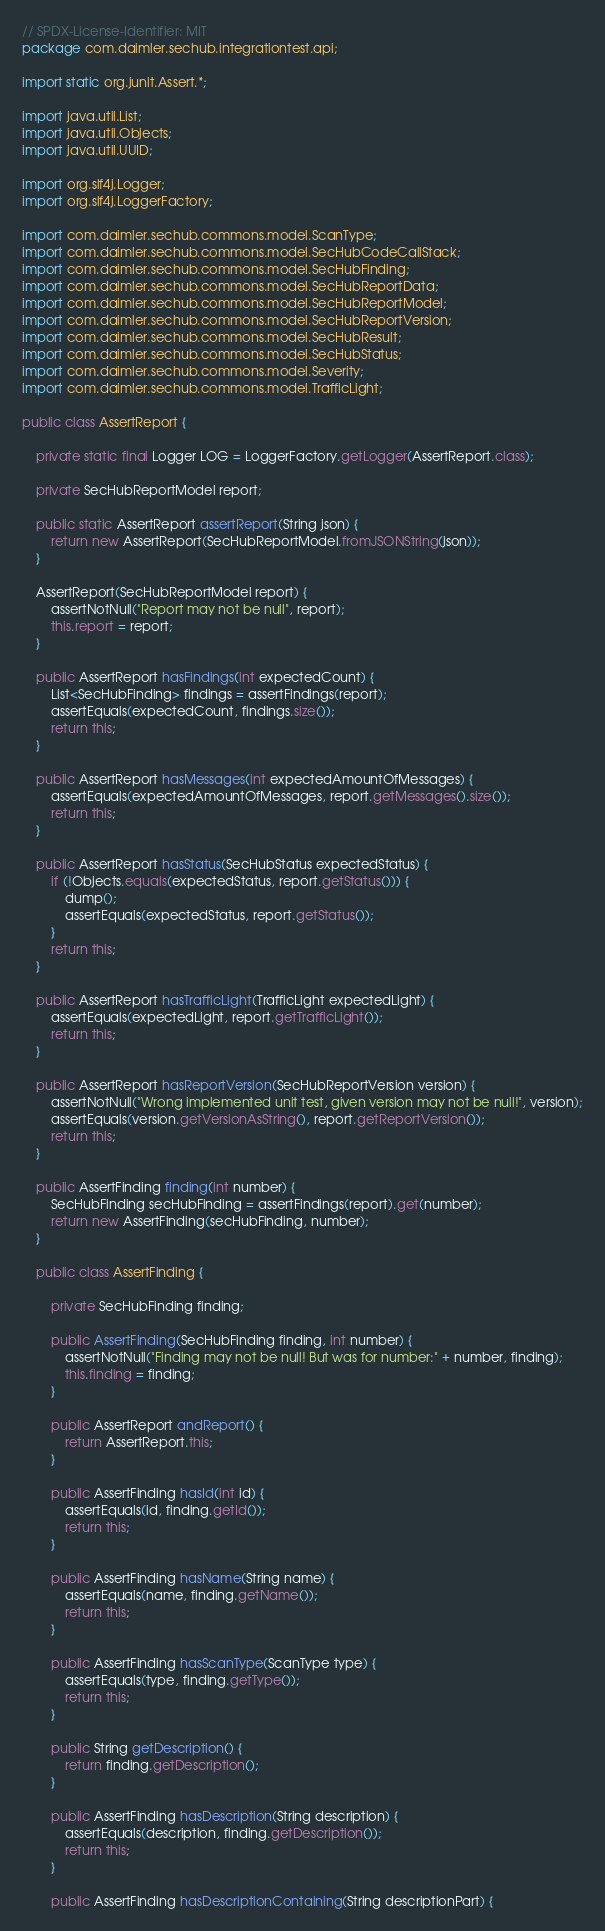Convert code to text. <code><loc_0><loc_0><loc_500><loc_500><_Java_>// SPDX-License-Identifier: MIT
package com.daimler.sechub.integrationtest.api;

import static org.junit.Assert.*;

import java.util.List;
import java.util.Objects;
import java.util.UUID;

import org.slf4j.Logger;
import org.slf4j.LoggerFactory;

import com.daimler.sechub.commons.model.ScanType;
import com.daimler.sechub.commons.model.SecHubCodeCallStack;
import com.daimler.sechub.commons.model.SecHubFinding;
import com.daimler.sechub.commons.model.SecHubReportData;
import com.daimler.sechub.commons.model.SecHubReportModel;
import com.daimler.sechub.commons.model.SecHubReportVersion;
import com.daimler.sechub.commons.model.SecHubResult;
import com.daimler.sechub.commons.model.SecHubStatus;
import com.daimler.sechub.commons.model.Severity;
import com.daimler.sechub.commons.model.TrafficLight;

public class AssertReport {

    private static final Logger LOG = LoggerFactory.getLogger(AssertReport.class);

    private SecHubReportModel report;

    public static AssertReport assertReport(String json) {
        return new AssertReport(SecHubReportModel.fromJSONString(json));
    }

    AssertReport(SecHubReportModel report) {
        assertNotNull("Report may not be null", report);
        this.report = report;
    }

    public AssertReport hasFindings(int expectedCount) {
        List<SecHubFinding> findings = assertFindings(report);
        assertEquals(expectedCount, findings.size());
        return this;
    }

    public AssertReport hasMessages(int expectedAmountOfMessages) {
        assertEquals(expectedAmountOfMessages, report.getMessages().size());
        return this;
    }

    public AssertReport hasStatus(SecHubStatus expectedStatus) {
        if (!Objects.equals(expectedStatus, report.getStatus())) {
            dump();
            assertEquals(expectedStatus, report.getStatus());
        }
        return this;
    }

    public AssertReport hasTrafficLight(TrafficLight expectedLight) {
        assertEquals(expectedLight, report.getTrafficLight());
        return this;
    }

    public AssertReport hasReportVersion(SecHubReportVersion version) {
        assertNotNull("Wrong implemented unit test, given version may not be null!", version);
        assertEquals(version.getVersionAsString(), report.getReportVersion());
        return this;
    }

    public AssertFinding finding(int number) {
        SecHubFinding secHubFinding = assertFindings(report).get(number);
        return new AssertFinding(secHubFinding, number);
    }

    public class AssertFinding {

        private SecHubFinding finding;

        public AssertFinding(SecHubFinding finding, int number) {
            assertNotNull("Finding may not be null! But was for number:" + number, finding);
            this.finding = finding;
        }

        public AssertReport andReport() {
            return AssertReport.this;
        }

        public AssertFinding hasId(int id) {
            assertEquals(id, finding.getId());
            return this;
        }

        public AssertFinding hasName(String name) {
            assertEquals(name, finding.getName());
            return this;
        }

        public AssertFinding hasScanType(ScanType type) {
            assertEquals(type, finding.getType());
            return this;
        }
        
        public String getDescription() {
            return finding.getDescription();
        }

        public AssertFinding hasDescription(String description) {
            assertEquals(description, finding.getDescription());
            return this;
        }

        public AssertFinding hasDescriptionContaining(String descriptionPart) {</code> 